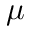Convert formula to latex. <formula><loc_0><loc_0><loc_500><loc_500>\mu</formula> 